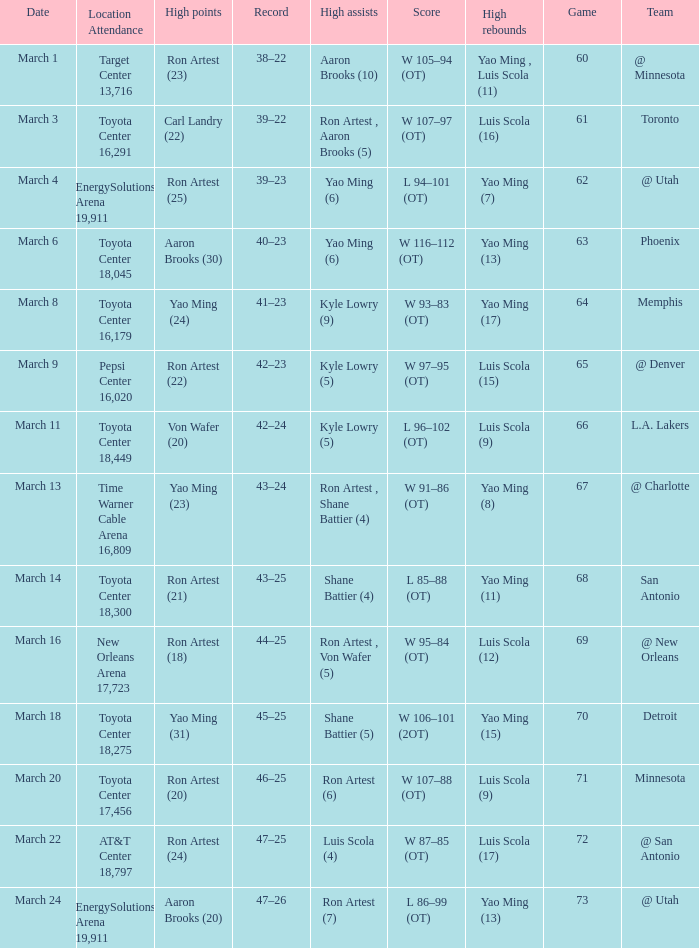On what date did the Rockets play Memphis? March 8. 